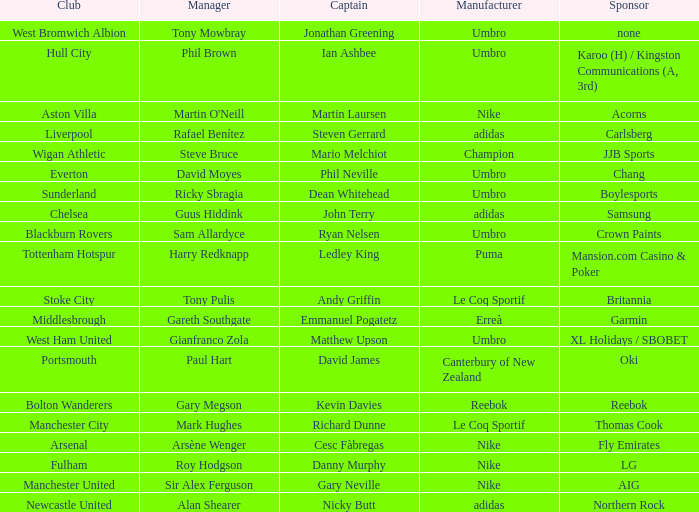Which Manchester United captain is sponsored by Nike? Gary Neville. 